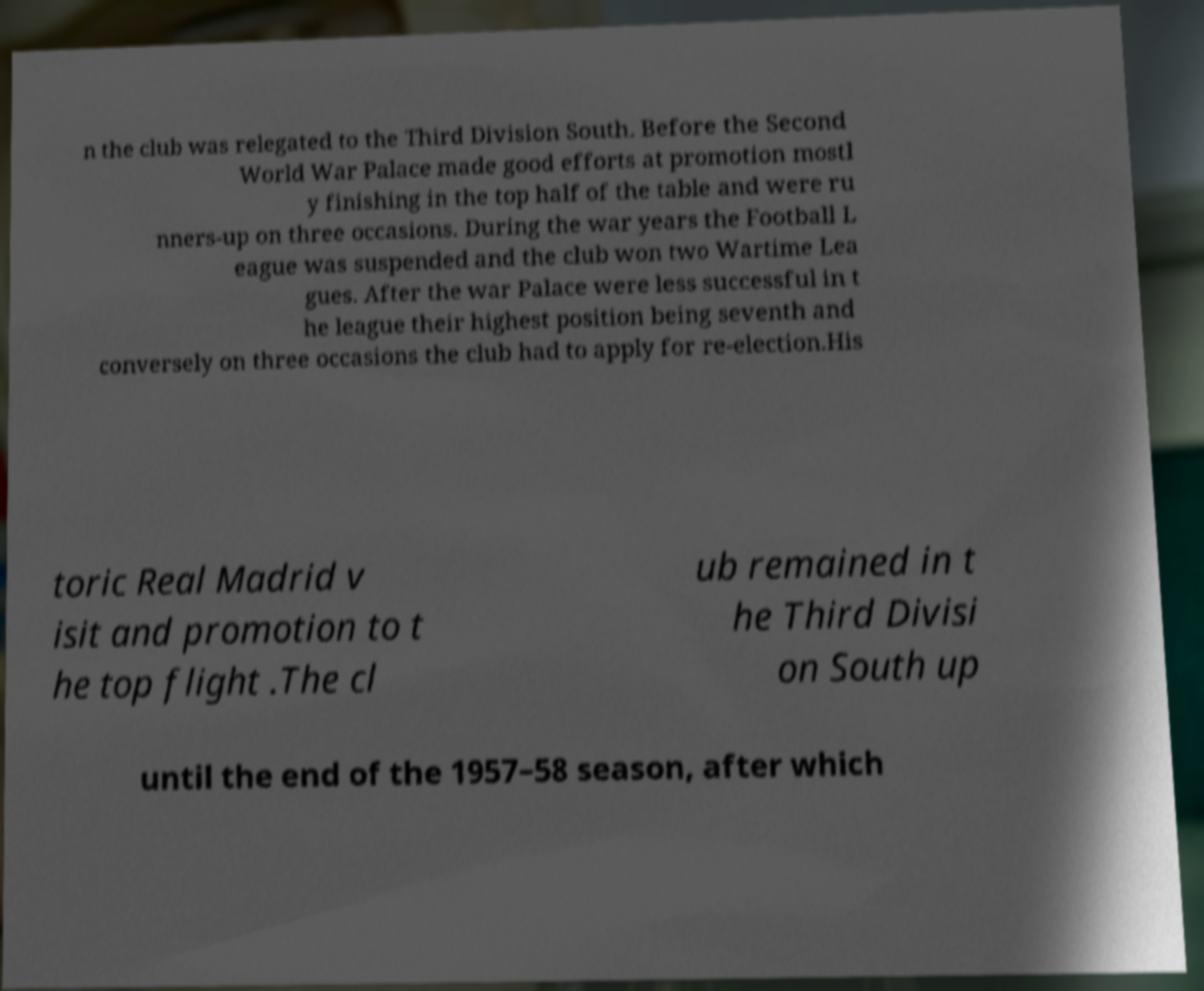Can you read and provide the text displayed in the image?This photo seems to have some interesting text. Can you extract and type it out for me? n the club was relegated to the Third Division South. Before the Second World War Palace made good efforts at promotion mostl y finishing in the top half of the table and were ru nners-up on three occasions. During the war years the Football L eague was suspended and the club won two Wartime Lea gues. After the war Palace were less successful in t he league their highest position being seventh and conversely on three occasions the club had to apply for re-election.His toric Real Madrid v isit and promotion to t he top flight .The cl ub remained in t he Third Divisi on South up until the end of the 1957–58 season, after which 